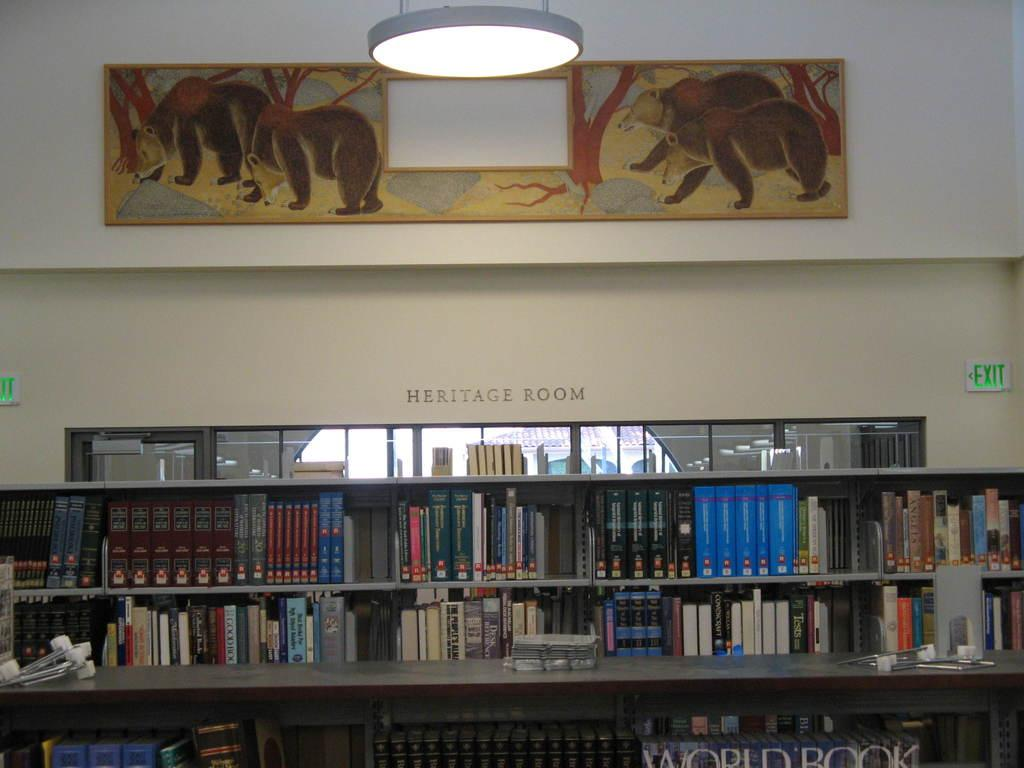Provide a one-sentence caption for the provided image. A book shelf full of books in the Heritage Room of a library. 